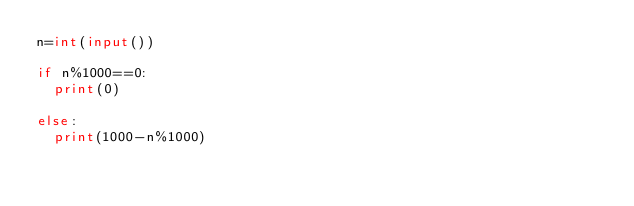Convert code to text. <code><loc_0><loc_0><loc_500><loc_500><_Python_>n=int(input())

if n%1000==0:
  print(0)
  
else:
  print(1000-n%1000)</code> 